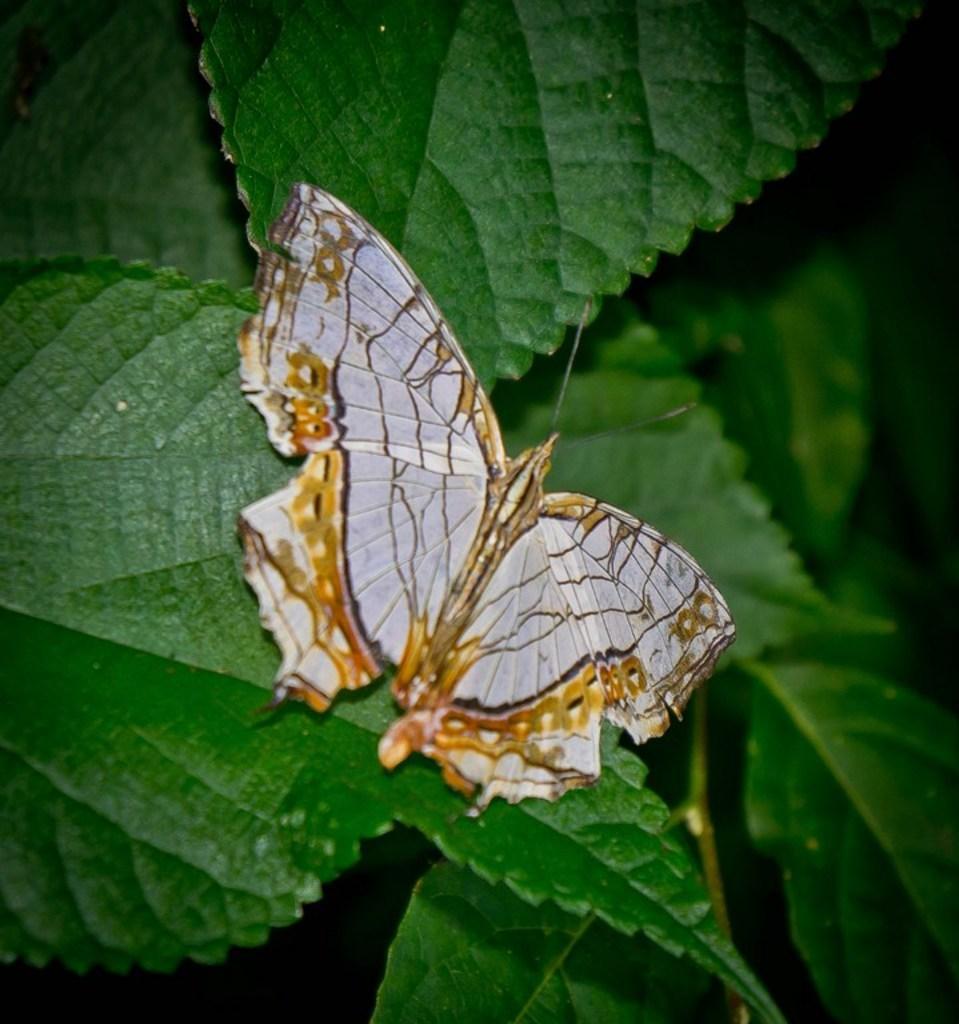Describe this image in one or two sentences. In this image we can see many leaves of the plant. There is a butterfly sitting on the leaf. 